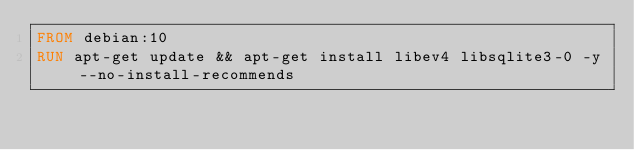Convert code to text. <code><loc_0><loc_0><loc_500><loc_500><_Dockerfile_>FROM debian:10
RUN apt-get update && apt-get install libev4 libsqlite3-0 -y --no-install-recommends
</code> 